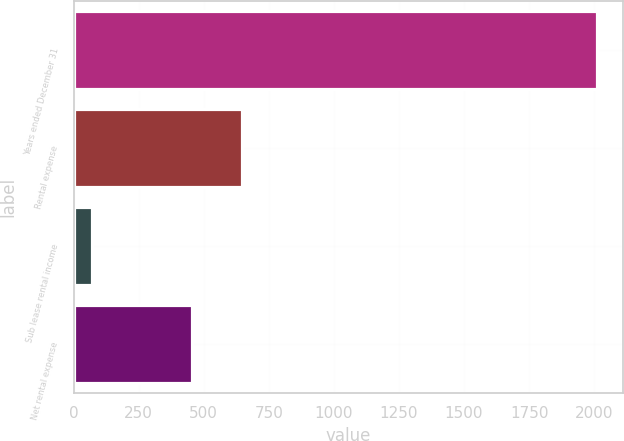<chart> <loc_0><loc_0><loc_500><loc_500><bar_chart><fcel>Years ended December 31<fcel>Rental expense<fcel>Sub lease rental income<fcel>Net rental expense<nl><fcel>2011<fcel>648<fcel>71<fcel>454<nl></chart> 